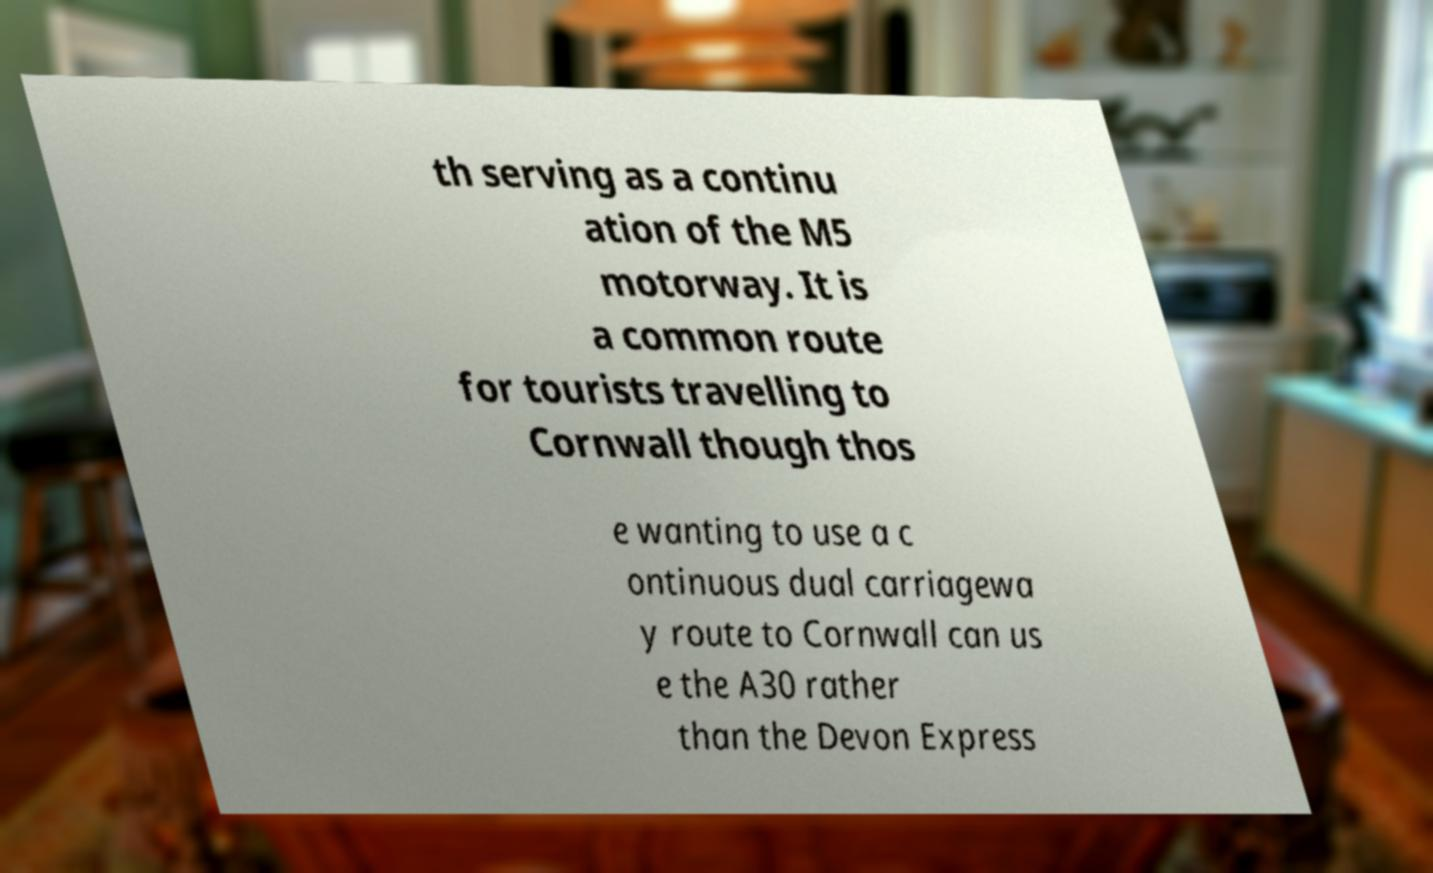Please identify and transcribe the text found in this image. th serving as a continu ation of the M5 motorway. It is a common route for tourists travelling to Cornwall though thos e wanting to use a c ontinuous dual carriagewa y route to Cornwall can us e the A30 rather than the Devon Express 